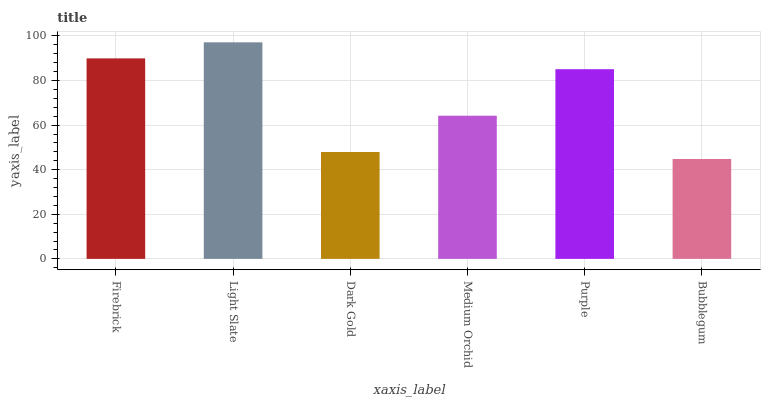Is Bubblegum the minimum?
Answer yes or no. Yes. Is Light Slate the maximum?
Answer yes or no. Yes. Is Dark Gold the minimum?
Answer yes or no. No. Is Dark Gold the maximum?
Answer yes or no. No. Is Light Slate greater than Dark Gold?
Answer yes or no. Yes. Is Dark Gold less than Light Slate?
Answer yes or no. Yes. Is Dark Gold greater than Light Slate?
Answer yes or no. No. Is Light Slate less than Dark Gold?
Answer yes or no. No. Is Purple the high median?
Answer yes or no. Yes. Is Medium Orchid the low median?
Answer yes or no. Yes. Is Medium Orchid the high median?
Answer yes or no. No. Is Bubblegum the low median?
Answer yes or no. No. 